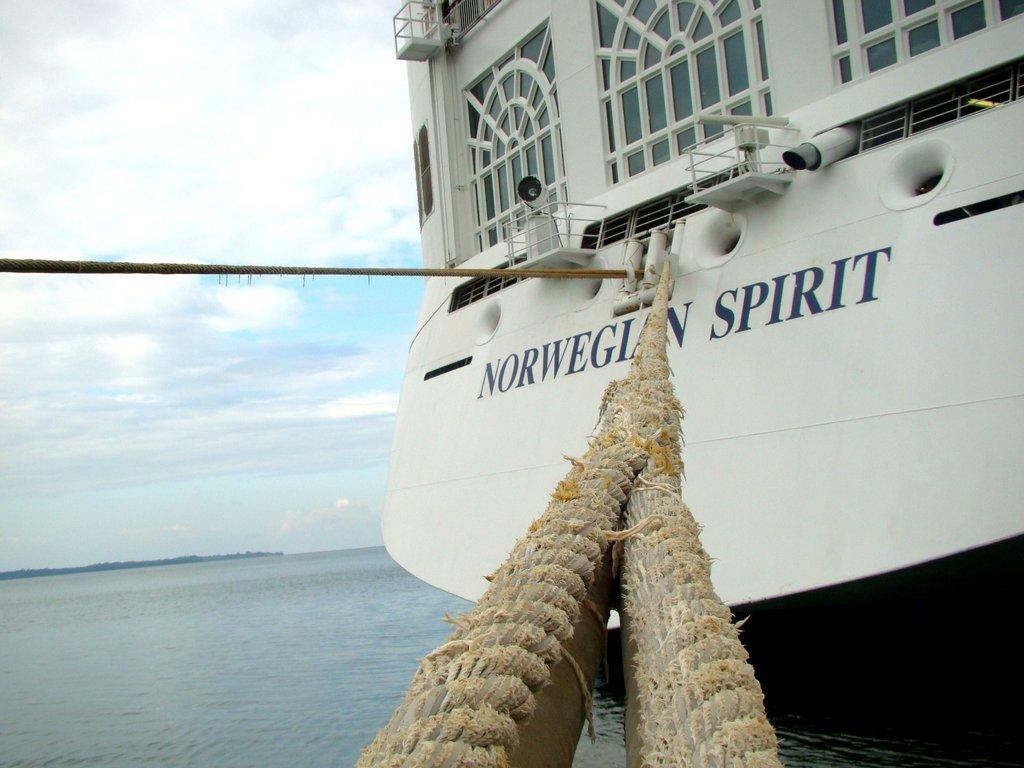How would you summarize this image in a sentence or two? This image is clicked outside. There is a boat in the middle. There is water at the bottom. There is sky at the top. 